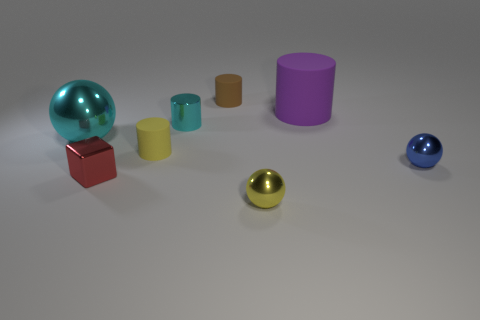How many other things are there of the same shape as the small brown thing?
Your answer should be compact. 3. What size is the matte cylinder that is both in front of the tiny brown cylinder and behind the big ball?
Provide a succinct answer. Large. How many rubber things are either cubes or yellow spheres?
Your answer should be compact. 0. There is a big object that is in front of the large matte object; does it have the same shape as the yellow object in front of the red metal cube?
Your answer should be very brief. Yes. Is there a yellow ball made of the same material as the block?
Keep it short and to the point. Yes. What color is the large metallic sphere?
Keep it short and to the point. Cyan. There is a matte thing that is in front of the big cyan metal ball; how big is it?
Provide a short and direct response. Small. How many other large cylinders are the same color as the shiny cylinder?
Make the answer very short. 0. Are there any big cyan shiny spheres in front of the shiny object on the right side of the yellow metallic sphere?
Provide a short and direct response. No. There is a small shiny ball that is right of the big matte thing; is it the same color as the big thing that is left of the yellow shiny object?
Offer a very short reply. No. 